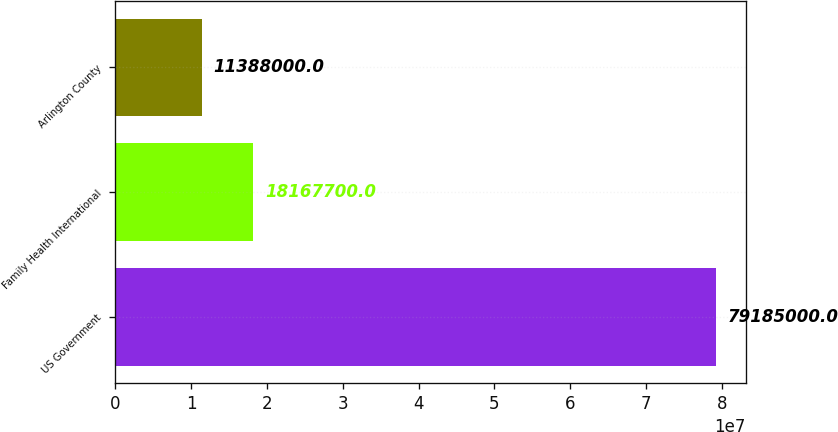<chart> <loc_0><loc_0><loc_500><loc_500><bar_chart><fcel>US Government<fcel>Family Health International<fcel>Arlington County<nl><fcel>7.9185e+07<fcel>1.81677e+07<fcel>1.1388e+07<nl></chart> 